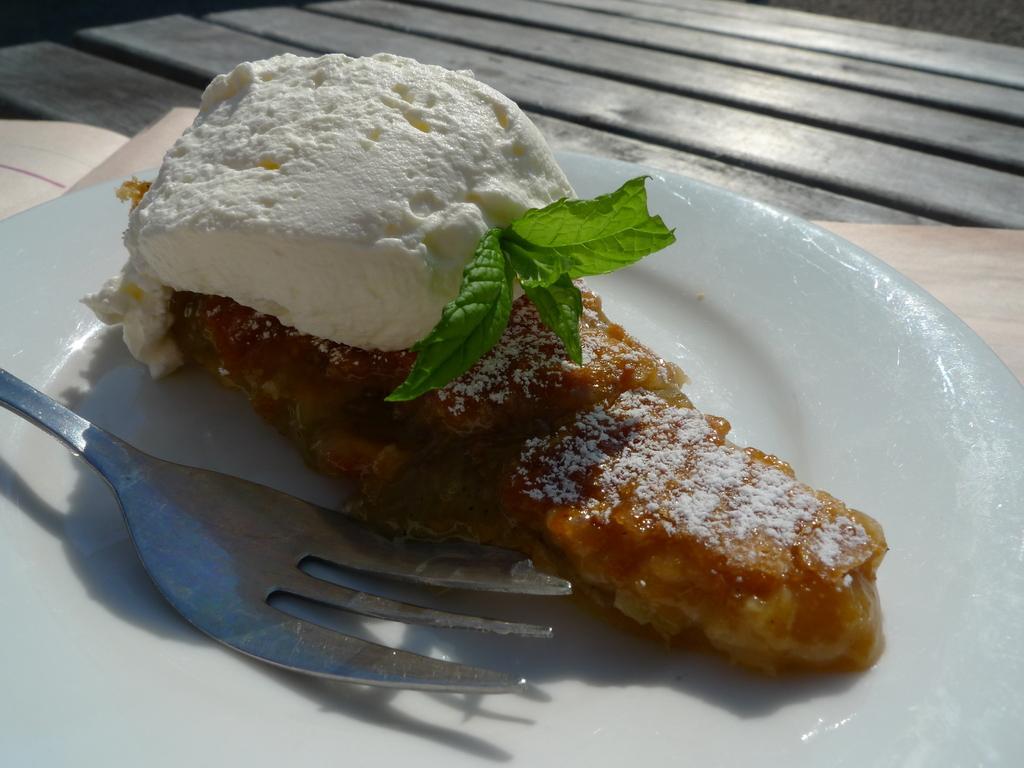In one or two sentences, can you explain what this image depicts? In this picture I can see a food item with a fork on the plate, on an object, and in the background there is a wooden table. 